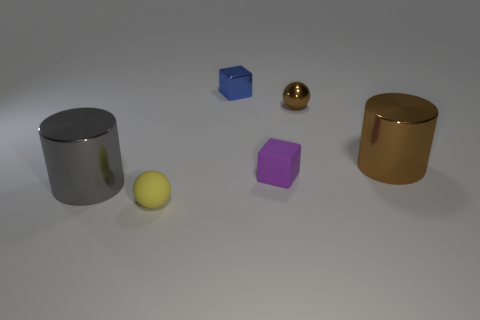Add 4 small matte cubes. How many objects exist? 10 Subtract all balls. How many objects are left? 4 Subtract all big brown objects. Subtract all tiny blue objects. How many objects are left? 4 Add 1 big brown metal things. How many big brown metal things are left? 2 Add 3 shiny things. How many shiny things exist? 7 Subtract 0 green balls. How many objects are left? 6 Subtract all brown spheres. Subtract all purple cylinders. How many spheres are left? 1 Subtract all purple blocks. How many brown cylinders are left? 1 